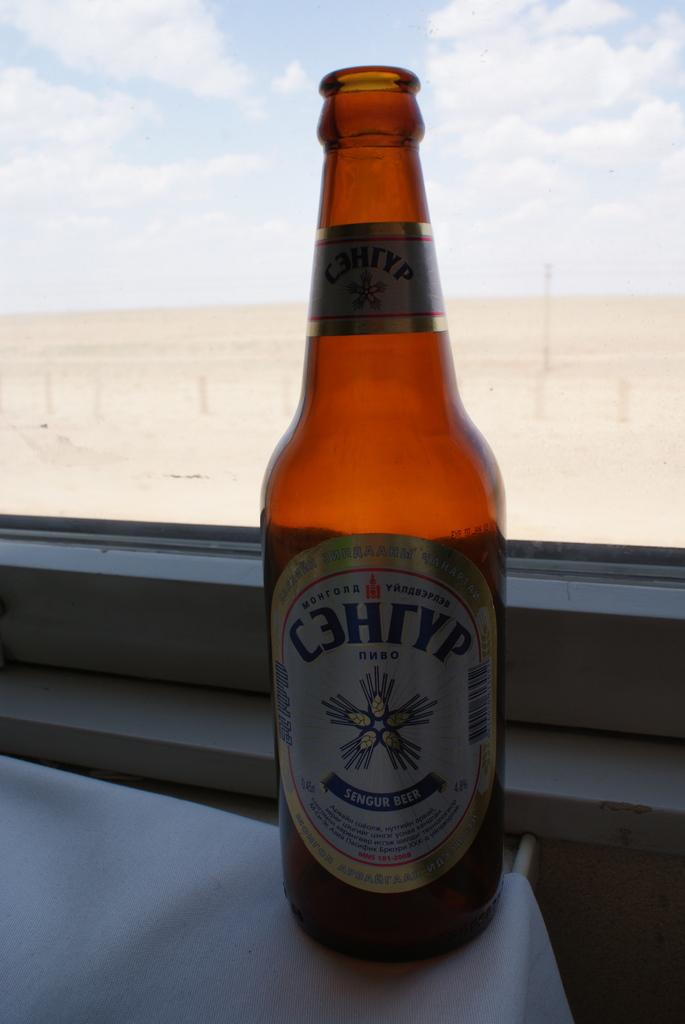<image>
Present a compact description of the photo's key features. Bottle of brown Sengur Beer in front of a window. 